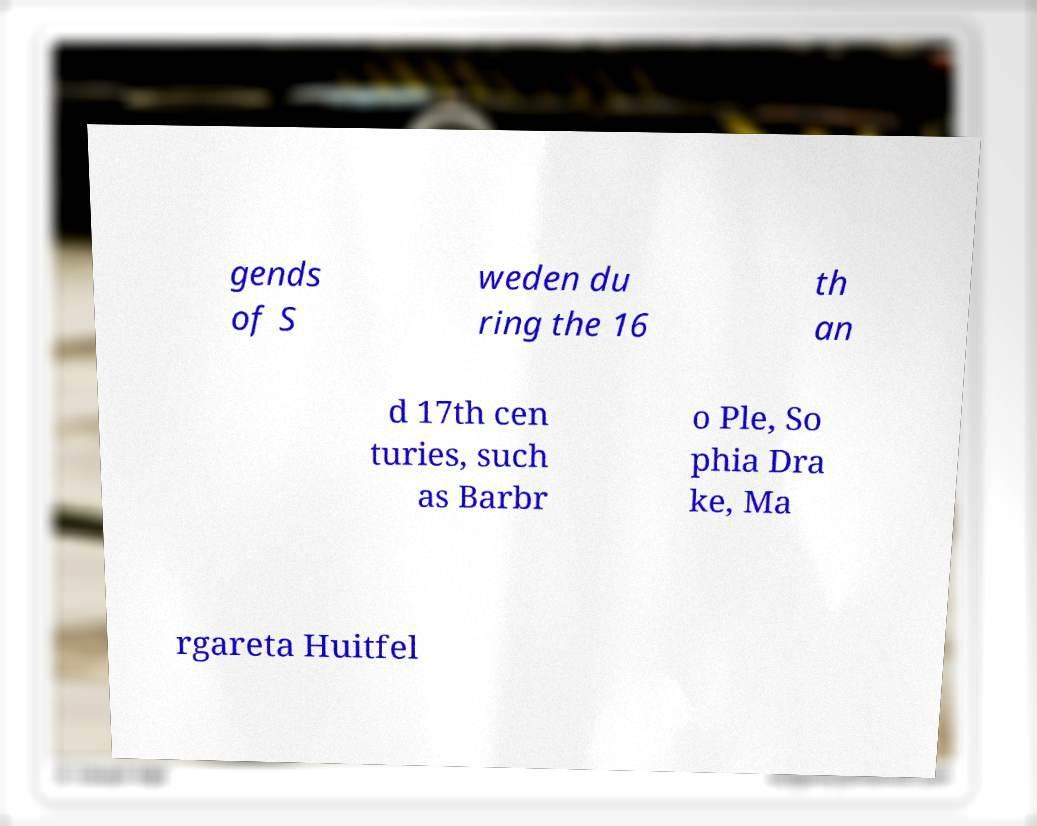For documentation purposes, I need the text within this image transcribed. Could you provide that? gends of S weden du ring the 16 th an d 17th cen turies, such as Barbr o Ple, So phia Dra ke, Ma rgareta Huitfel 